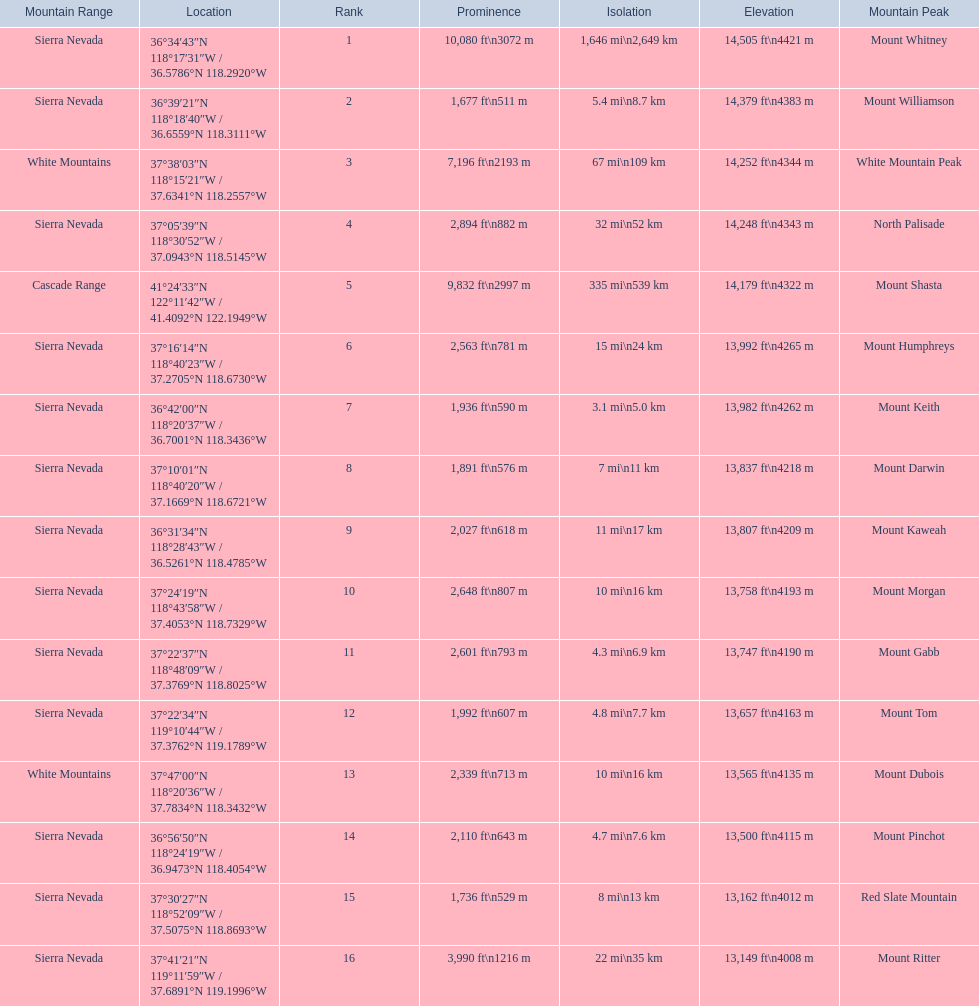What are all of the mountain peaks? Mount Whitney, Mount Williamson, White Mountain Peak, North Palisade, Mount Shasta, Mount Humphreys, Mount Keith, Mount Darwin, Mount Kaweah, Mount Morgan, Mount Gabb, Mount Tom, Mount Dubois, Mount Pinchot, Red Slate Mountain, Mount Ritter. Could you parse the entire table as a dict? {'header': ['Mountain Range', 'Location', 'Rank', 'Prominence', 'Isolation', 'Elevation', 'Mountain Peak'], 'rows': [['Sierra Nevada', '36°34′43″N 118°17′31″W\ufeff / \ufeff36.5786°N 118.2920°W', '1', '10,080\xa0ft\\n3072\xa0m', '1,646\xa0mi\\n2,649\xa0km', '14,505\xa0ft\\n4421\xa0m', 'Mount Whitney'], ['Sierra Nevada', '36°39′21″N 118°18′40″W\ufeff / \ufeff36.6559°N 118.3111°W', '2', '1,677\xa0ft\\n511\xa0m', '5.4\xa0mi\\n8.7\xa0km', '14,379\xa0ft\\n4383\xa0m', 'Mount Williamson'], ['White Mountains', '37°38′03″N 118°15′21″W\ufeff / \ufeff37.6341°N 118.2557°W', '3', '7,196\xa0ft\\n2193\xa0m', '67\xa0mi\\n109\xa0km', '14,252\xa0ft\\n4344\xa0m', 'White Mountain Peak'], ['Sierra Nevada', '37°05′39″N 118°30′52″W\ufeff / \ufeff37.0943°N 118.5145°W', '4', '2,894\xa0ft\\n882\xa0m', '32\xa0mi\\n52\xa0km', '14,248\xa0ft\\n4343\xa0m', 'North Palisade'], ['Cascade Range', '41°24′33″N 122°11′42″W\ufeff / \ufeff41.4092°N 122.1949°W', '5', '9,832\xa0ft\\n2997\xa0m', '335\xa0mi\\n539\xa0km', '14,179\xa0ft\\n4322\xa0m', 'Mount Shasta'], ['Sierra Nevada', '37°16′14″N 118°40′23″W\ufeff / \ufeff37.2705°N 118.6730°W', '6', '2,563\xa0ft\\n781\xa0m', '15\xa0mi\\n24\xa0km', '13,992\xa0ft\\n4265\xa0m', 'Mount Humphreys'], ['Sierra Nevada', '36°42′00″N 118°20′37″W\ufeff / \ufeff36.7001°N 118.3436°W', '7', '1,936\xa0ft\\n590\xa0m', '3.1\xa0mi\\n5.0\xa0km', '13,982\xa0ft\\n4262\xa0m', 'Mount Keith'], ['Sierra Nevada', '37°10′01″N 118°40′20″W\ufeff / \ufeff37.1669°N 118.6721°W', '8', '1,891\xa0ft\\n576\xa0m', '7\xa0mi\\n11\xa0km', '13,837\xa0ft\\n4218\xa0m', 'Mount Darwin'], ['Sierra Nevada', '36°31′34″N 118°28′43″W\ufeff / \ufeff36.5261°N 118.4785°W', '9', '2,027\xa0ft\\n618\xa0m', '11\xa0mi\\n17\xa0km', '13,807\xa0ft\\n4209\xa0m', 'Mount Kaweah'], ['Sierra Nevada', '37°24′19″N 118°43′58″W\ufeff / \ufeff37.4053°N 118.7329°W', '10', '2,648\xa0ft\\n807\xa0m', '10\xa0mi\\n16\xa0km', '13,758\xa0ft\\n4193\xa0m', 'Mount Morgan'], ['Sierra Nevada', '37°22′37″N 118°48′09″W\ufeff / \ufeff37.3769°N 118.8025°W', '11', '2,601\xa0ft\\n793\xa0m', '4.3\xa0mi\\n6.9\xa0km', '13,747\xa0ft\\n4190\xa0m', 'Mount Gabb'], ['Sierra Nevada', '37°22′34″N 119°10′44″W\ufeff / \ufeff37.3762°N 119.1789°W', '12', '1,992\xa0ft\\n607\xa0m', '4.8\xa0mi\\n7.7\xa0km', '13,657\xa0ft\\n4163\xa0m', 'Mount Tom'], ['White Mountains', '37°47′00″N 118°20′36″W\ufeff / \ufeff37.7834°N 118.3432°W', '13', '2,339\xa0ft\\n713\xa0m', '10\xa0mi\\n16\xa0km', '13,565\xa0ft\\n4135\xa0m', 'Mount Dubois'], ['Sierra Nevada', '36°56′50″N 118°24′19″W\ufeff / \ufeff36.9473°N 118.4054°W', '14', '2,110\xa0ft\\n643\xa0m', '4.7\xa0mi\\n7.6\xa0km', '13,500\xa0ft\\n4115\xa0m', 'Mount Pinchot'], ['Sierra Nevada', '37°30′27″N 118°52′09″W\ufeff / \ufeff37.5075°N 118.8693°W', '15', '1,736\xa0ft\\n529\xa0m', '8\xa0mi\\n13\xa0km', '13,162\xa0ft\\n4012\xa0m', 'Red Slate Mountain'], ['Sierra Nevada', '37°41′21″N 119°11′59″W\ufeff / \ufeff37.6891°N 119.1996°W', '16', '3,990\xa0ft\\n1216\xa0m', '22\xa0mi\\n35\xa0km', '13,149\xa0ft\\n4008\xa0m', 'Mount Ritter']]} In what ranges are they? Sierra Nevada, Sierra Nevada, White Mountains, Sierra Nevada, Cascade Range, Sierra Nevada, Sierra Nevada, Sierra Nevada, Sierra Nevada, Sierra Nevada, Sierra Nevada, Sierra Nevada, White Mountains, Sierra Nevada, Sierra Nevada, Sierra Nevada. Which peak is in the cascade range? Mount Shasta. 